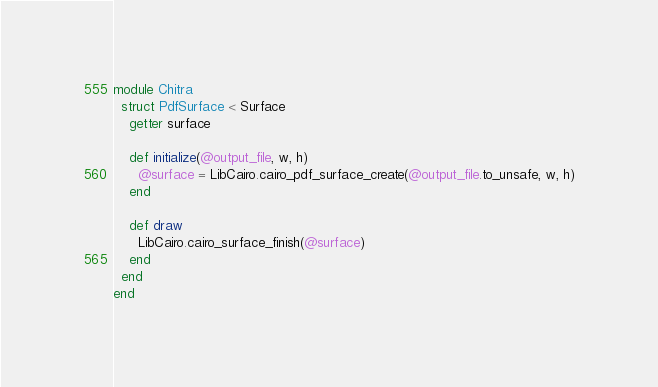<code> <loc_0><loc_0><loc_500><loc_500><_Crystal_>module Chitra
  struct PdfSurface < Surface
    getter surface

    def initialize(@output_file, w, h)
      @surface = LibCairo.cairo_pdf_surface_create(@output_file.to_unsafe, w, h)
    end

    def draw
      LibCairo.cairo_surface_finish(@surface)
    end
  end
end
</code> 